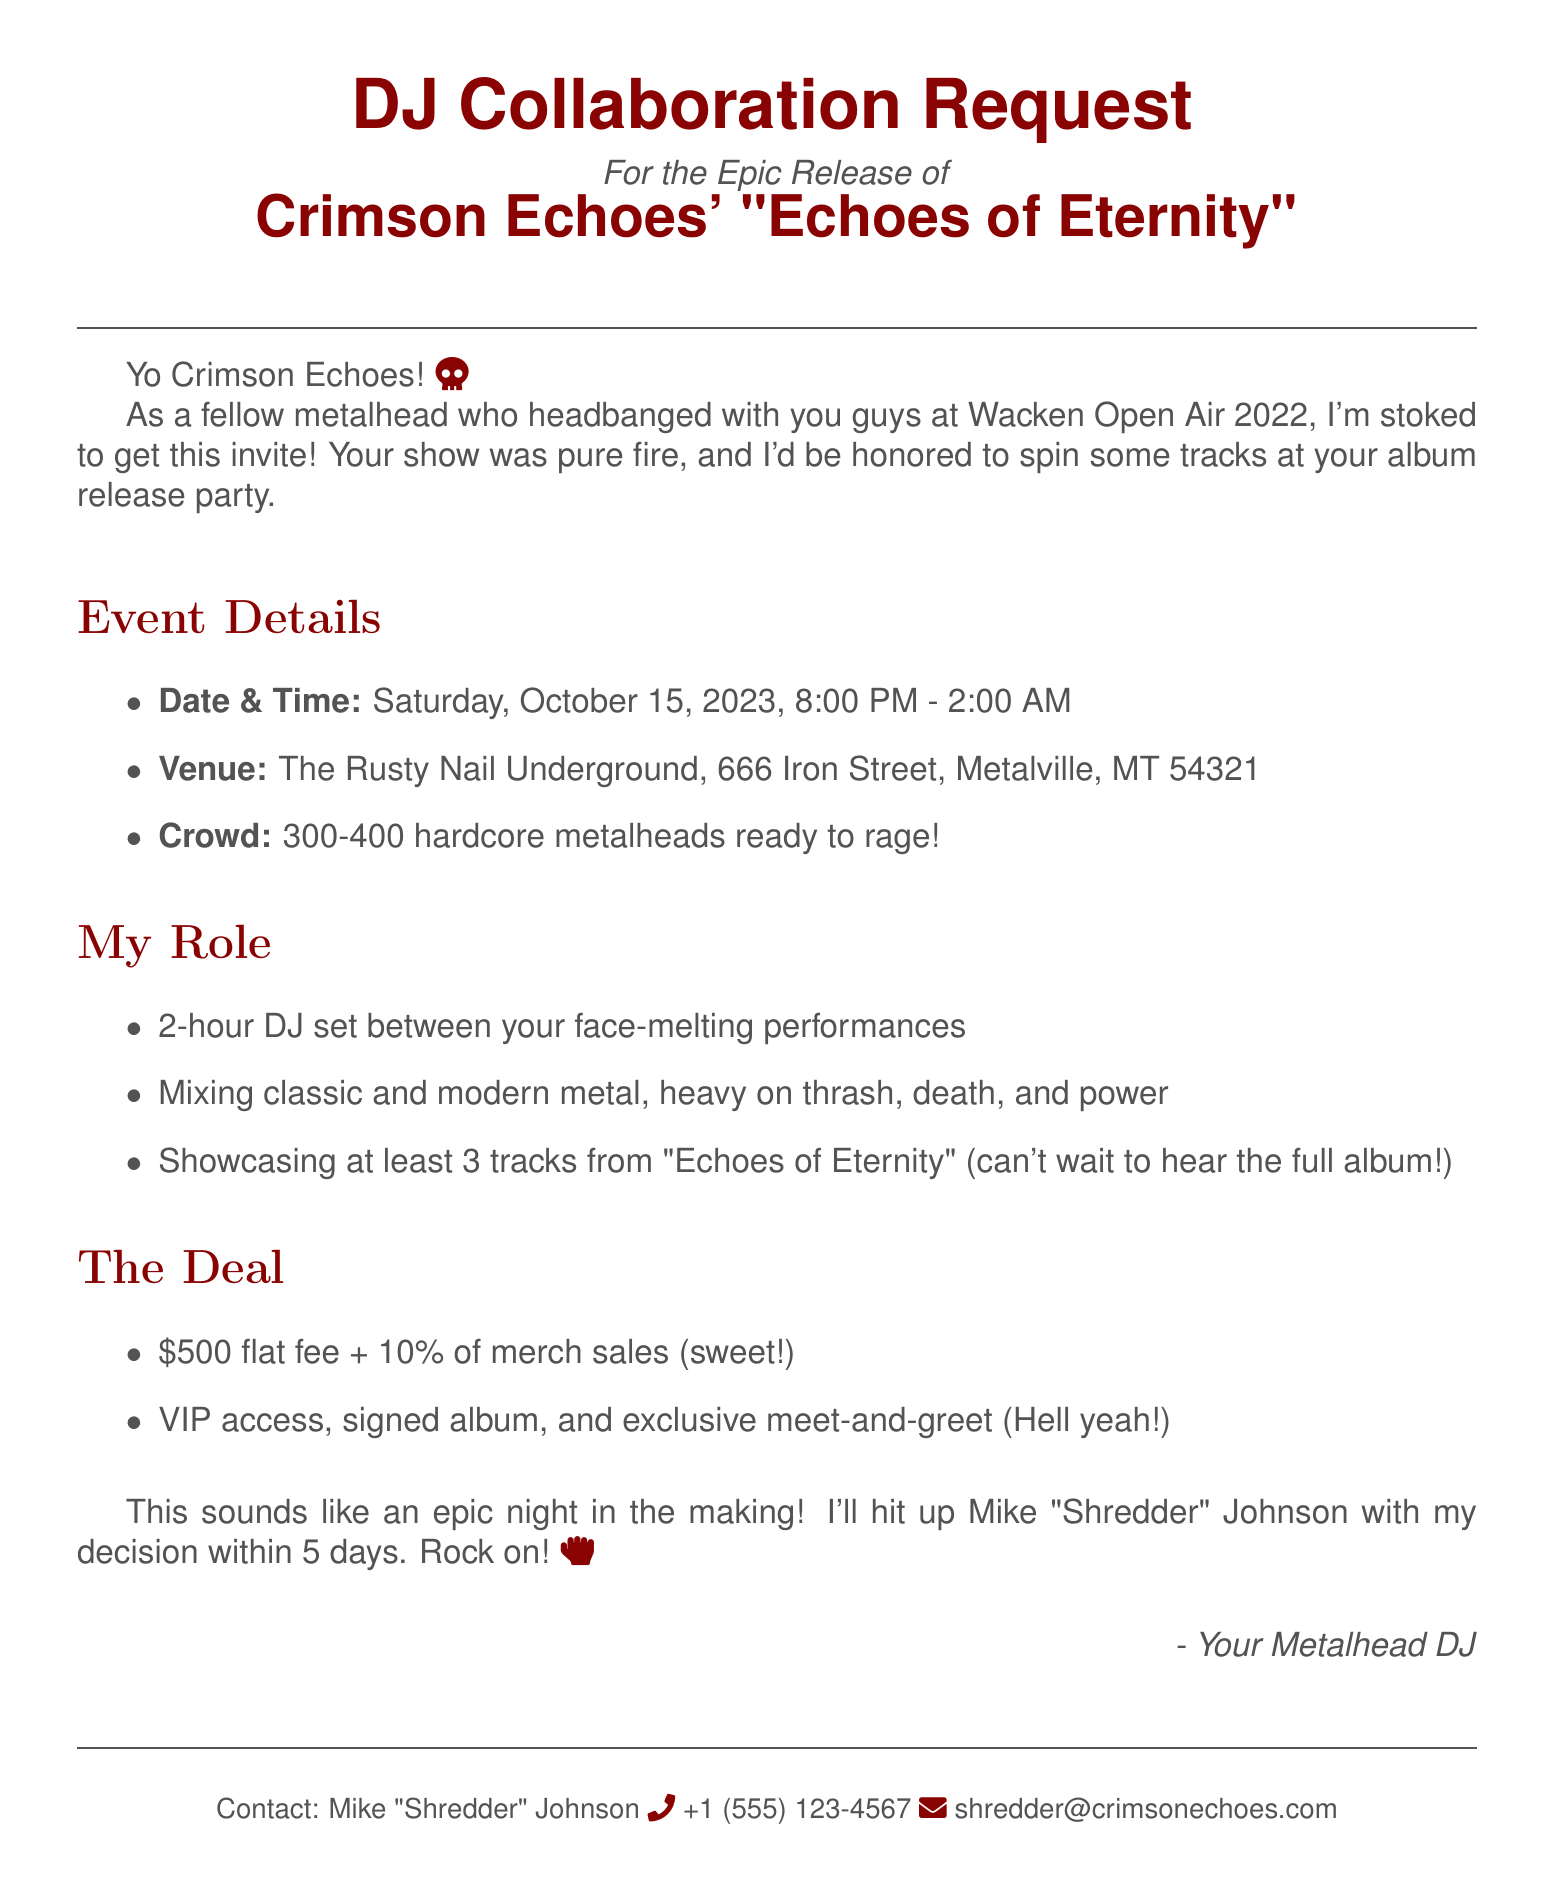What is the band name? The band name is specified at the beginning of the document.
Answer: Crimson Echoes What is the album title? The album title is mentioned right after the band introduction.
Answer: Echoes of Eternity What is the event date? The event date is highlighted under the event details section.
Answer: Saturday, October 15, 2023 What is the compensation offer for the DJ? The compensation offer is listed in the "The Deal" section of the document.
Answer: $500 flat fee plus 10% of merch sales How long is the DJ set duration? The DJ set duration is detailed under the "My Role" section.
Answer: 2 hours Who should be contacted for more information? The contact person is provided in the footer of the document.
Answer: Mike 'Shredder' Johnson What is the venue for the event? The venue is specified under the event details.
Answer: The Rusty Nail Underground What type of music is requested for the DJ set? The requested music style is mentioned in the "My Role" section.
Answer: Mix of classic and modern metal How many attendees are expected? The expected attendance is included in the event details.
Answer: 300-400 metalheads When is the response deadline? The response deadline is stated at the end of the document.
Answer: Within 5 business days 